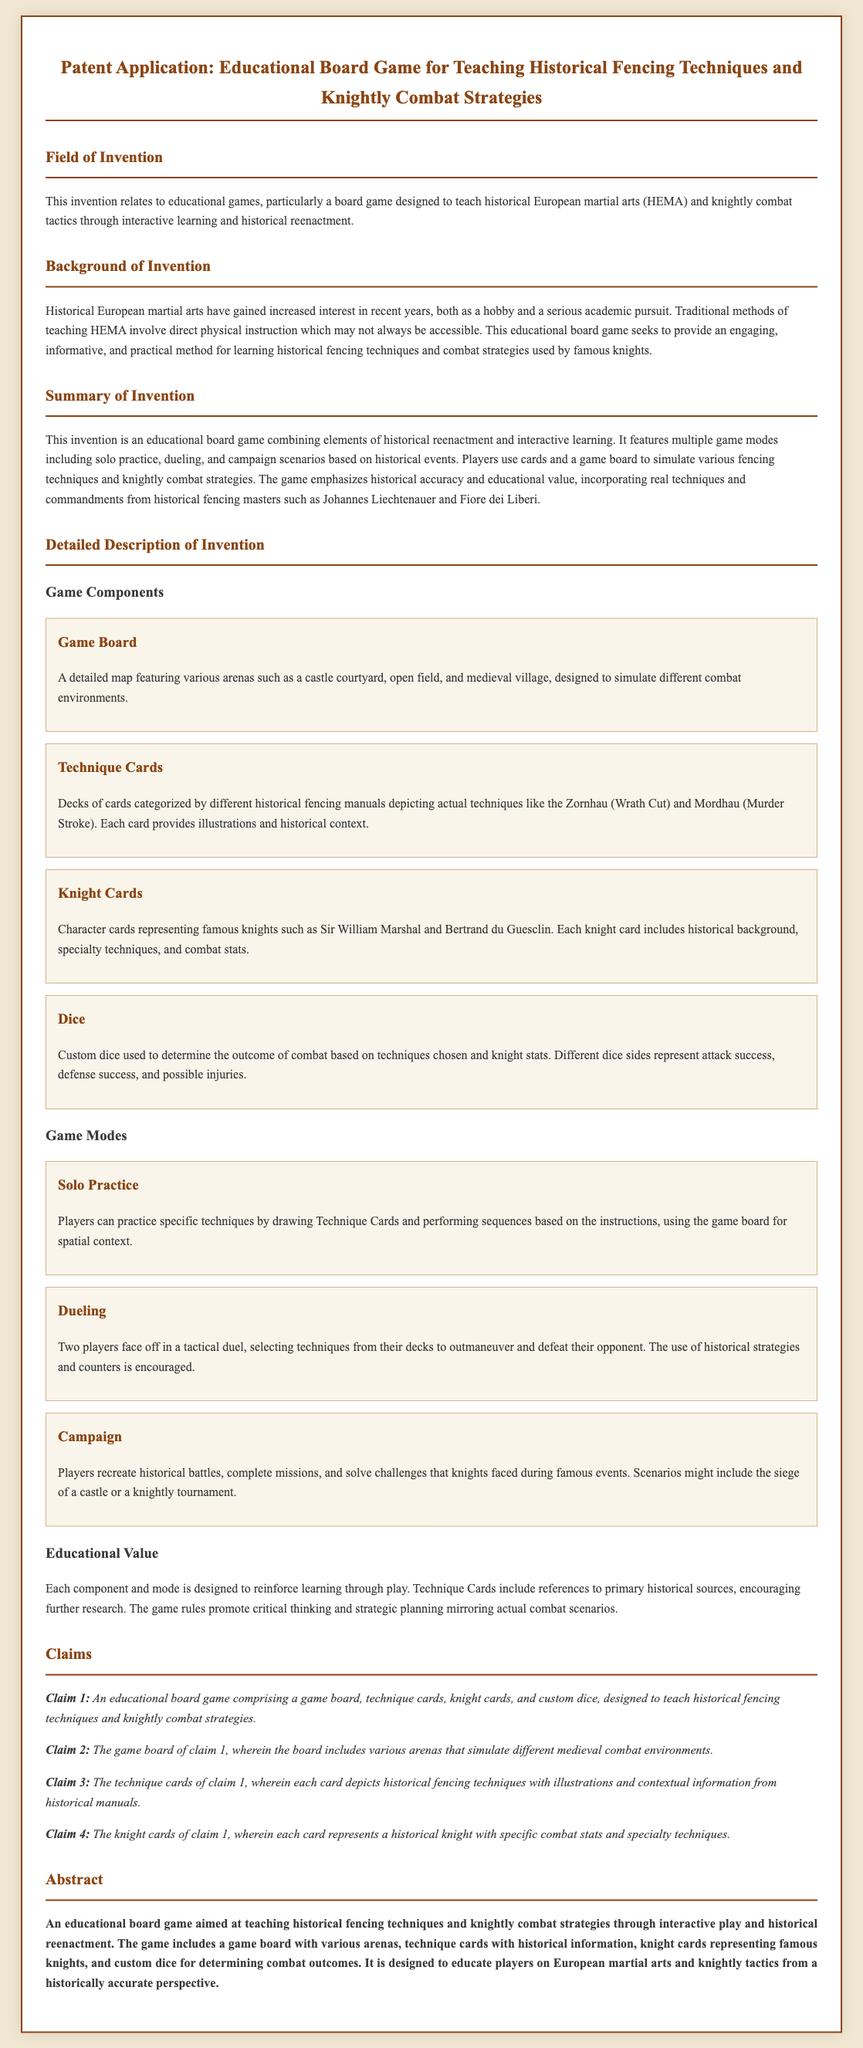What is the field of invention? The field of invention is specified as an educational game, particularly a board game designed to teach historical European martial arts and knightly combat tactics.
Answer: Educational games Who are two historical figures represented by knight cards? The document mentions Sir William Marshal and Bertrand du Guesclin as knights represented in the game.
Answer: Sir William Marshal and Bertrand du Guesclin What does the game board feature? The game board is described as a detailed map featuring various arenas such as a castle courtyard, open field, and medieval village.
Answer: Various arenas How many claims are listed in the document? The claims section includes four distinct claims related to the game's components and features.
Answer: Four What educational benefit does the game provide? The game is designed to educate players on European martial arts and knightly tactics from a historically accurate perspective.
Answer: Historical accuracy What type of dice is included in the game? The game includes custom dice used to determine the outcome of combat based on techniques chosen and knight stats.
Answer: Custom dice 